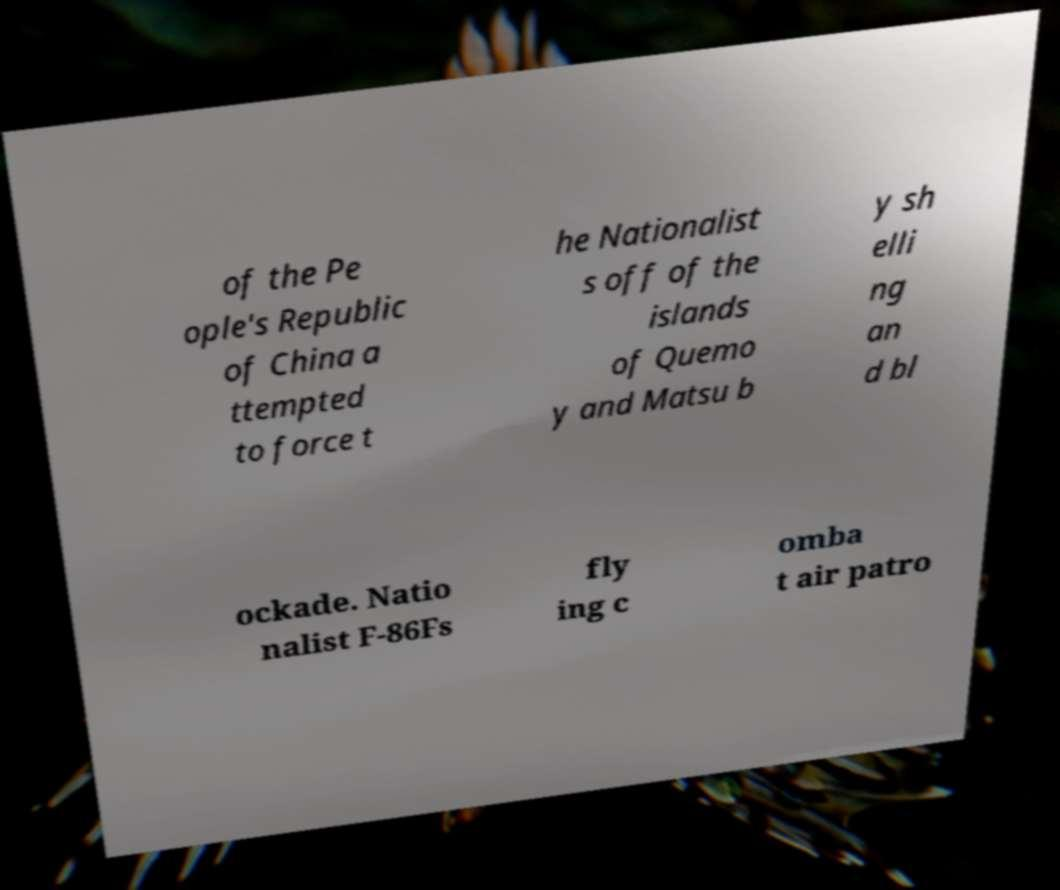What messages or text are displayed in this image? I need them in a readable, typed format. of the Pe ople's Republic of China a ttempted to force t he Nationalist s off of the islands of Quemo y and Matsu b y sh elli ng an d bl ockade. Natio nalist F-86Fs fly ing c omba t air patro 